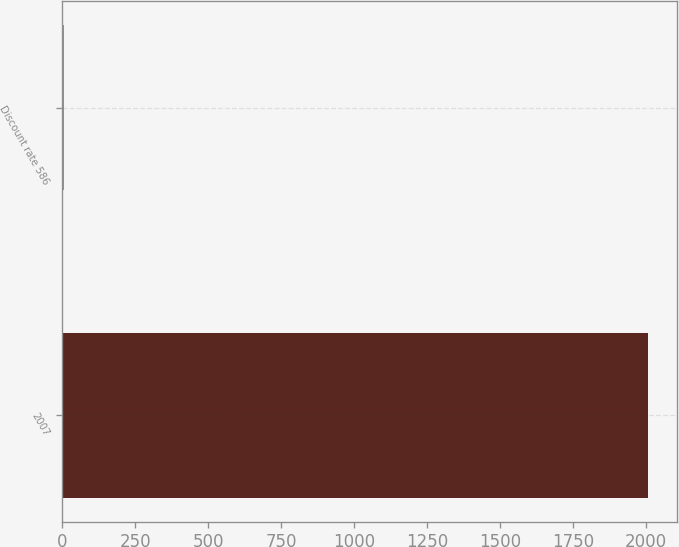Convert chart. <chart><loc_0><loc_0><loc_500><loc_500><bar_chart><fcel>2007<fcel>Discount rate 586<nl><fcel>2006<fcel>5.52<nl></chart> 